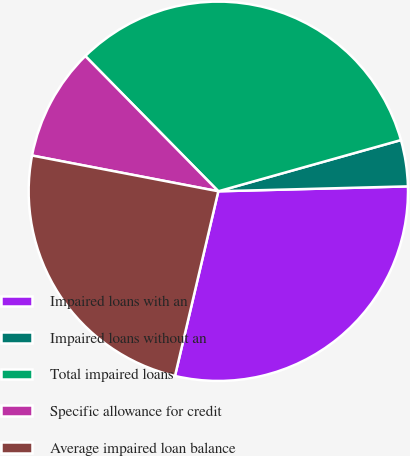Convert chart to OTSL. <chart><loc_0><loc_0><loc_500><loc_500><pie_chart><fcel>Impaired loans with an<fcel>Impaired loans without an<fcel>Total impaired loans<fcel>Specific allowance for credit<fcel>Average impaired loan balance<nl><fcel>29.08%<fcel>3.94%<fcel>33.02%<fcel>9.61%<fcel>24.35%<nl></chart> 